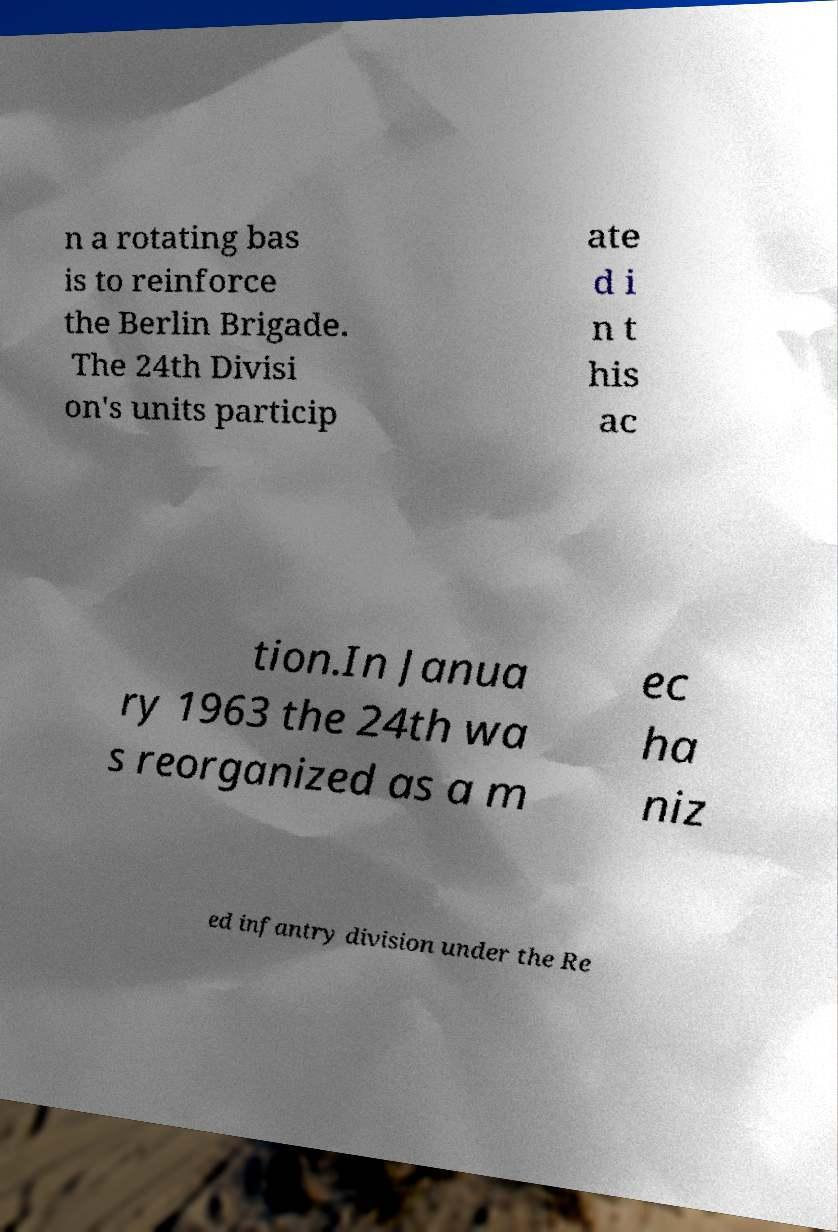For documentation purposes, I need the text within this image transcribed. Could you provide that? n a rotating bas is to reinforce the Berlin Brigade. The 24th Divisi on's units particip ate d i n t his ac tion.In Janua ry 1963 the 24th wa s reorganized as a m ec ha niz ed infantry division under the Re 